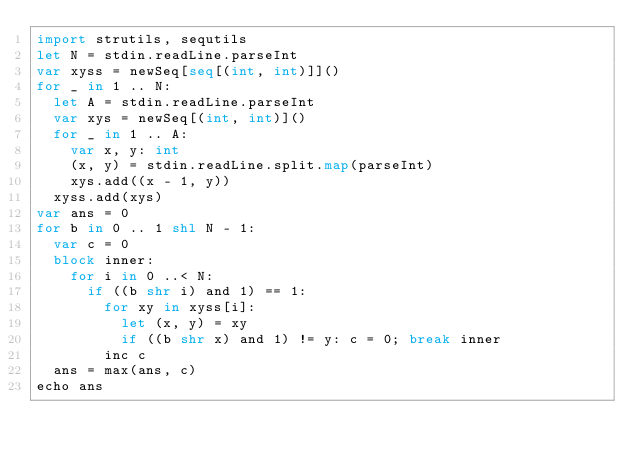Convert code to text. <code><loc_0><loc_0><loc_500><loc_500><_Nim_>import strutils, sequtils
let N = stdin.readLine.parseInt
var xyss = newSeq[seq[(int, int)]]()
for _ in 1 .. N:
  let A = stdin.readLine.parseInt
  var xys = newSeq[(int, int)]()
  for _ in 1 .. A:
    var x, y: int
    (x, y) = stdin.readLine.split.map(parseInt)
    xys.add((x - 1, y))
  xyss.add(xys)
var ans = 0
for b in 0 .. 1 shl N - 1:
  var c = 0
  block inner:
    for i in 0 ..< N:
      if ((b shr i) and 1) == 1:
        for xy in xyss[i]:
          let (x, y) = xy
          if ((b shr x) and 1) != y: c = 0; break inner
        inc c
  ans = max(ans, c)
echo ans</code> 